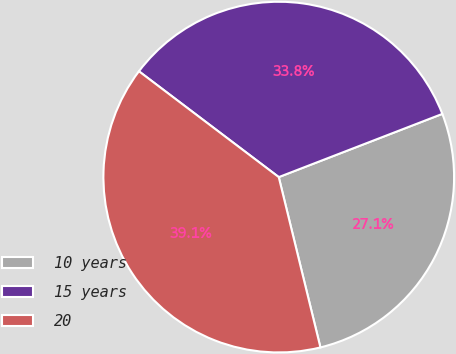Convert chart to OTSL. <chart><loc_0><loc_0><loc_500><loc_500><pie_chart><fcel>10 years<fcel>15 years<fcel>20<nl><fcel>27.05%<fcel>33.82%<fcel>39.13%<nl></chart> 